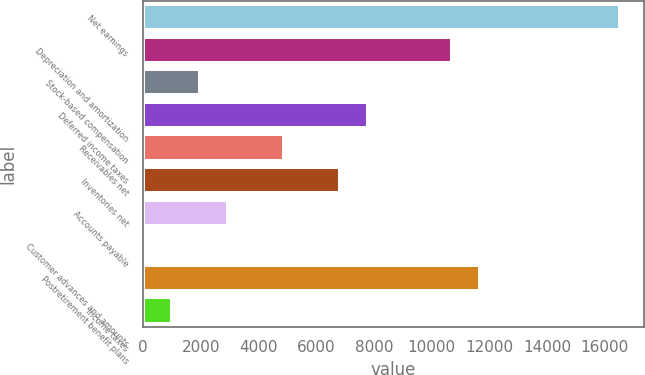<chart> <loc_0><loc_0><loc_500><loc_500><bar_chart><fcel>Net earnings<fcel>Depreciation and amortization<fcel>Stock-based compensation<fcel>Deferred income taxes<fcel>Receivables net<fcel>Inventories net<fcel>Accounts payable<fcel>Customer advances and amounts<fcel>Postretirement benefit plans<fcel>Income taxes<nl><fcel>16525.4<fcel>10704.2<fcel>1972.4<fcel>7793.6<fcel>4883<fcel>6823.4<fcel>2942.6<fcel>32<fcel>11674.4<fcel>1002.2<nl></chart> 